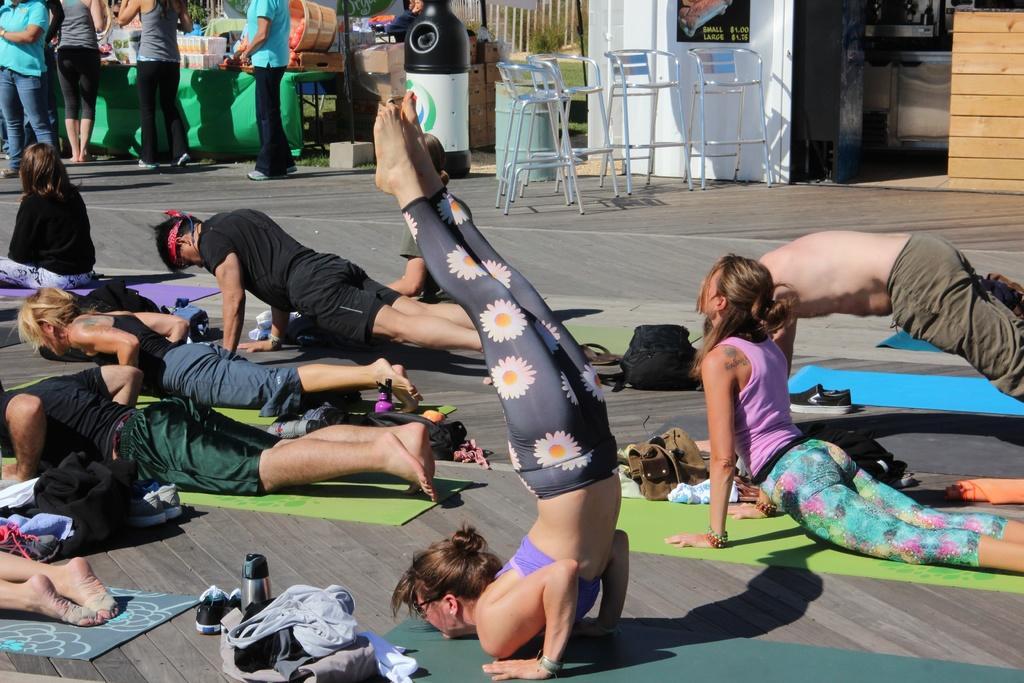How would you summarize this image in a sentence or two? In this image we can see few people doing yoga on the yoga mat. There are clothes and bags. Also there are bottles. In the back there are chairs. And there is a dustbin. And there are few people standing. And there are few items in the background. And there is a wall with a poster. 